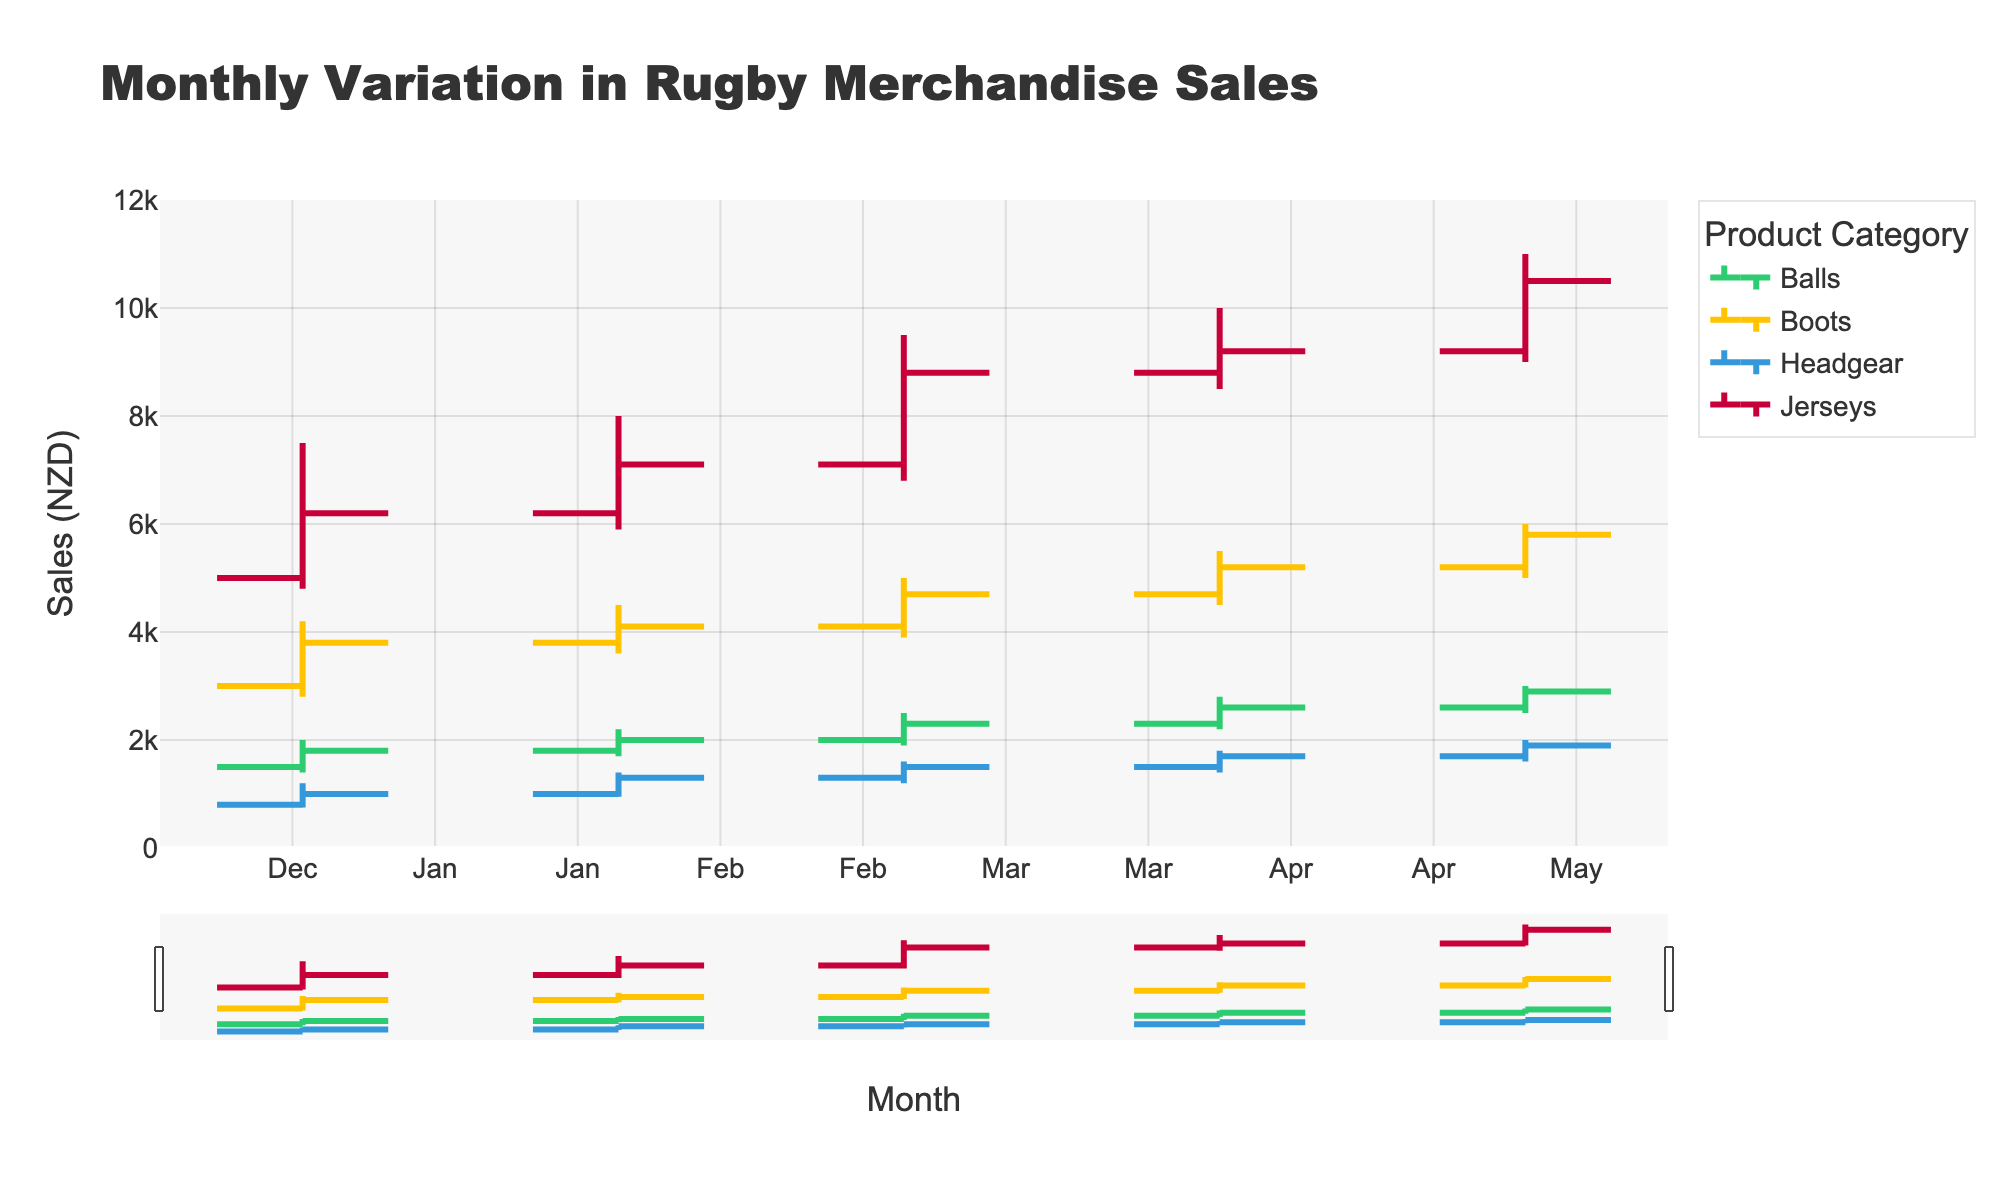What is the title of the figure? The title of the figure is located at the top center of the chart and provides an overview of what is being depicted.
Answer: Monthly Variation in Rugby Merchandise Sales Which product showed the highest sale in any given month? The "High" column for Jerseys shows a value of 11,000 in May, which is the highest individual sales figure for any product in any month.
Answer: Jerseys In which month did the Boots category have the lowest sale? Observing the "Low" column for Boots, the lowest value is 2,800 in January.
Answer: January What was the close value for Balls in March? The "Close" value for Balls in March is listed in the dataset as 2,300.
Answer: 2,300 Compare the closing sales of Jerseys from February to March. What is the difference? The closing value for Jerseys in February is 7,100 and in March it is 8,800. The difference is calculated as 8,800 - 7,100 = 1,700.
Answer: 1,700 Which product had an increasing trend throughout all months? An increasing trend is observed when the close value is higher than the open value and each month shows a progressive increase. For Boots, the closing values progressively increase from January (3,800) to May (5,800).
Answer: Boots During which month did Headgear have its highest value and what was the value? Observing the "High" column for Headgear, April has the highest value of 1,800.
Answer: April and 1,800 What is the average opening value of Jerseys across all months? Summing up the opening values for Jerseys (5,000 + 6,200 + 7,100 + 8,800 + 9,200) and dividing by 5, we get (5,000 + 6,200 + 7,100 + 8,800 + 9,200) / 5 = 36,300 / 5 = 7,260.
Answer: 7,260 In which month did Balls category see the highest closing sales? Observing the "Close" values for Balls, May shows the highest closing sales value of 2,900.
Answer: May Which products had a decrease in sales from January to February? A decrease in sales is observed by comparing the closing values from January to February. For Jerseys, the closing value increased from 6,200 in January to 7,100 in February. For Boots, the value increased from 3,800 in January to 4,100 in February. For Balls, it increased from 1,800 in January to 2,000 in February. For Headgear, it increased from 1,000 in January to 1,300 in February. Thus, no product showed a decrease in sales from January to February.
Answer: None 